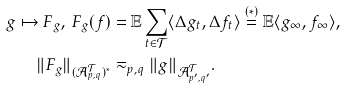Convert formula to latex. <formula><loc_0><loc_0><loc_500><loc_500>g \mapsto F _ { g } , \, F _ { g } ( f ) & = \mathbb { E } \sum _ { t \in \mathcal { T } } \langle \Delta g _ { t } , \Delta f _ { t } \rangle \stackrel { ( * ) } = \mathbb { E } \langle g _ { \infty } , f _ { \infty } \rangle , \\ \| F _ { g } \| _ { ( \mathcal { A } ^ { \mathcal { T } } _ { p , q } ) ^ { * } } & \eqsim _ { p , q } \| g \| _ { \mathcal { A } ^ { \mathcal { T } } _ { p ^ { \prime } , q ^ { \prime } } } .</formula> 